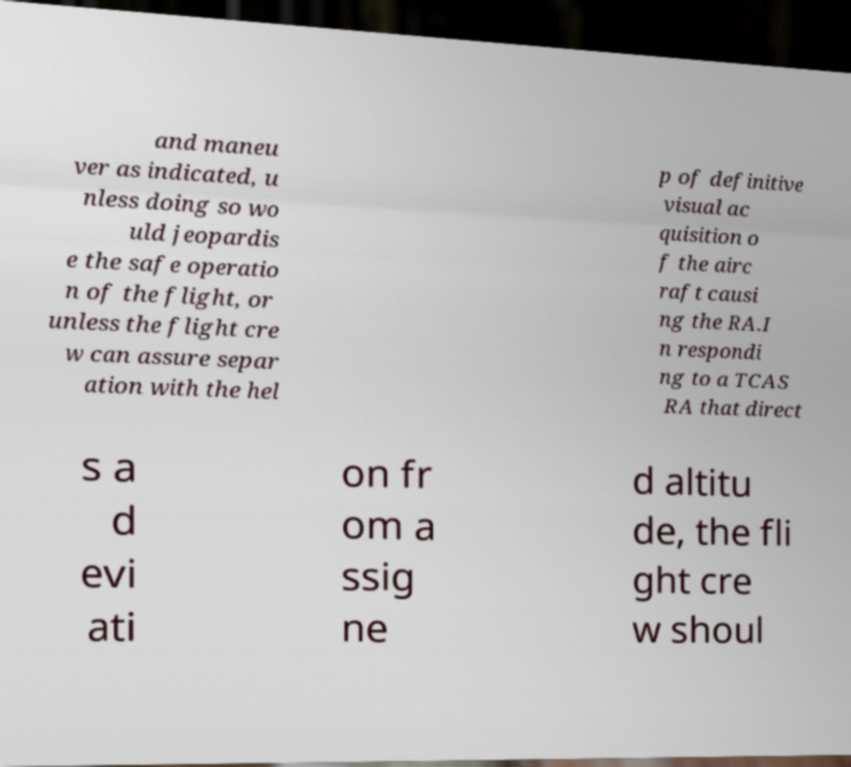Please identify and transcribe the text found in this image. and maneu ver as indicated, u nless doing so wo uld jeopardis e the safe operatio n of the flight, or unless the flight cre w can assure separ ation with the hel p of definitive visual ac quisition o f the airc raft causi ng the RA.I n respondi ng to a TCAS RA that direct s a d evi ati on fr om a ssig ne d altitu de, the fli ght cre w shoul 